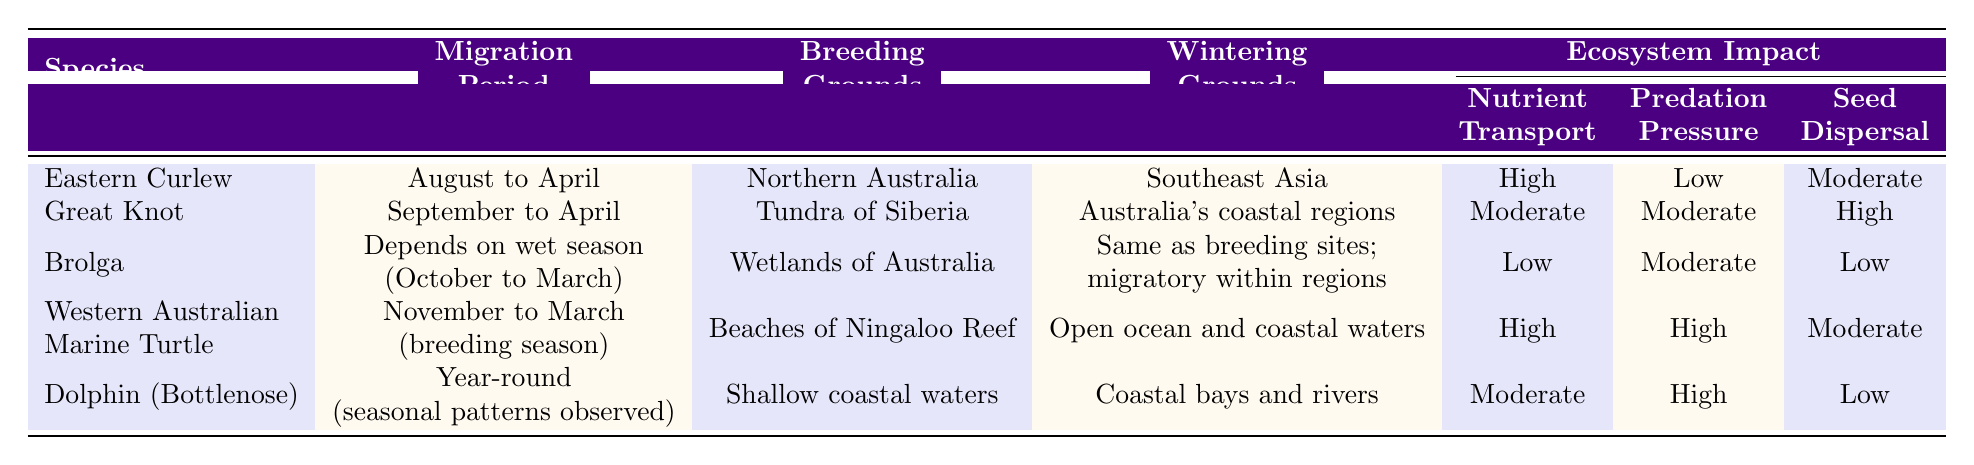What is the migration period for the Eastern Curlew? The table lists the migration period for the Eastern Curlew as "August to April" in the relevant column.
Answer: August to April Which species has the highest nutrient transport impact? By comparing the nutrient transport impact values for all species, the Western Australian Marine Turtle shows a "High" impact, which is the highest value in the table.
Answer: Western Australian Marine Turtle Does the Brolga have a high seed dispersal impact? The Brolga's seed dispersal impact is listed as "Low" in the table, indicating it does not have a high impact.
Answer: No What are the breeding grounds for the Great Knot? The breeding grounds for the Great Knot are specified in the table as "Tundra of Siberia."
Answer: Tundra of Siberia Which species migrates year-round, and how does its predation pressure compare to others? The Dolphin (Bottlenose) migrates year-round, and its predation pressure is noted as "High." Comparing this with other species, it has one of the higher levels of predation pressure in the table.
Answer: Dolphin (Bottlenose); High What is the average seed dispersal impact of all species listed? The seed dispersal values are: Moderate (Eastern Curlew), High (Great Knot), Low (Brolga), Moderate (Western Australian Marine Turtle), and Low (Dolphin). Converting these to a numerical scale: Moderate = 2, High = 3, Low = 1, we have (2 + 3 + 1 + 2 + 1) = 9, divided by 5 species results in an average of 1.8, which can generally be considered as approximately "Moderate."
Answer: Moderate Which species has the lowest predation pressure? By assessing the predation pressure for each species, the Eastern Curlew shows "Low," making it the species with the least predation pressure according to the table.
Answer: Eastern Curlew If the migration period of the Western Australian Marine Turtle is primarily during breeding season, what months does it cover? The table states the migration period for the Western Australian Marine Turtle is from "November to March," which corresponds to its breeding season.
Answer: November to March What is the combined nutrient transport impact for both the Eastern Curlew and Western Australian Marine Turtle? The Eastern Curlew has "High" nutrient transport, and the Western Australian Marine Turtle also has "High." By assuming a scale (High = 2), the combined impact could be described as "High" since both species contribute positively to nutrient transport.
Answer: High How many species have moderate or high seed dispersal impact? The species with moderate or high seed dispersal include the Great Knot (High), and the Eastern Curlew and Western Australian Marine Turtle (Moderate). Counting gives us three species that fit this description.
Answer: 3 